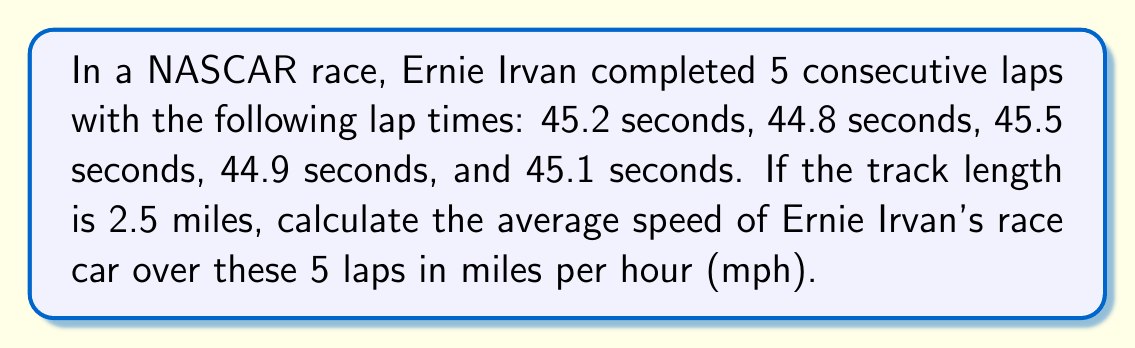Teach me how to tackle this problem. Let's approach this step-by-step:

1) First, we need to calculate the total time for all 5 laps:
   $45.2 + 44.8 + 45.5 + 44.9 + 45.1 = 225.5$ seconds

2) Now, we need to convert this time to hours:
   $225.5 \text{ seconds} = \frac{225.5}{3600} \text{ hours} = 0.0626389 \text{ hours}$

3) Next, we calculate the total distance covered:
   $5 \text{ laps} \times 2.5 \text{ miles per lap} = 12.5 \text{ miles}$

4) The formula for average speed is:
   $$\text{Average Speed} = \frac{\text{Total Distance}}{\text{Total Time}}$$

5) Plugging in our values:
   $$\text{Average Speed} = \frac{12.5 \text{ miles}}{0.0626389 \text{ hours}}$$

6) Calculating:
   $$\text{Average Speed} = 199.56 \text{ mph}$$

7) Rounding to two decimal places:
   $$\text{Average Speed} \approx 199.56 \text{ mph}$$
Answer: 199.56 mph 